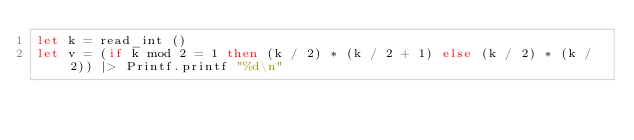<code> <loc_0><loc_0><loc_500><loc_500><_OCaml_>let k = read_int ()
let v = (if k mod 2 = 1 then (k / 2) * (k / 2 + 1) else (k / 2) * (k / 2)) |> Printf.printf "%d\n"</code> 